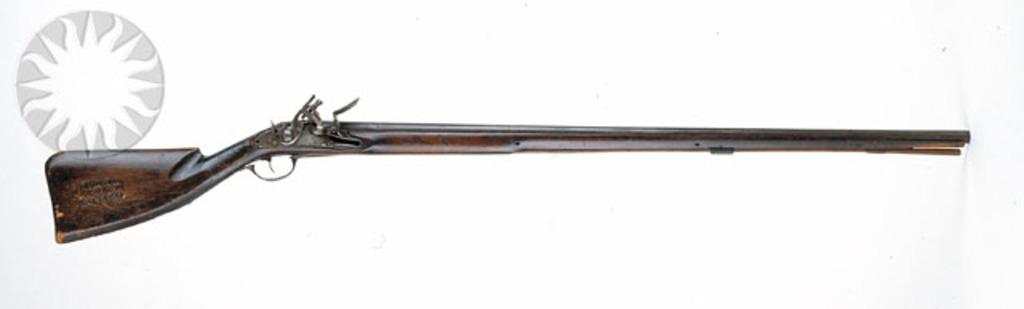What object is placed on the surface in the image? There is a gun on the surface in the image. What additional item can be seen in the image? There is a sticker in the image. What division does the owner of the gun belong to in the image? There is no information about the owner of the gun in the image, so we cannot determine which division they might belong to. 